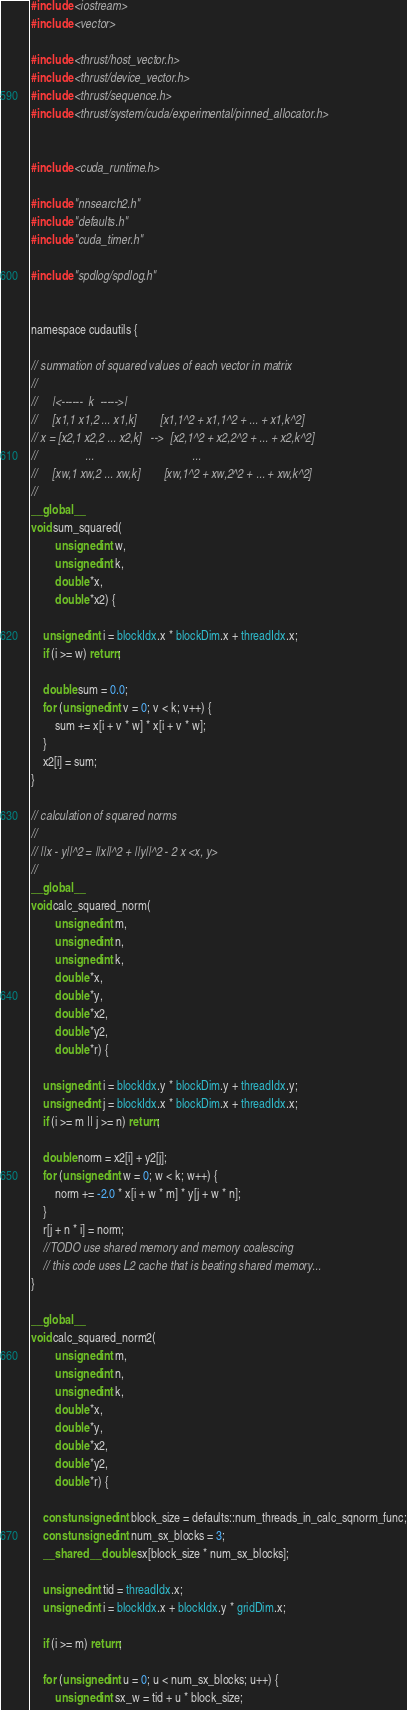Convert code to text. <code><loc_0><loc_0><loc_500><loc_500><_Cuda_>#include <iostream>
#include <vector>

#include <thrust/host_vector.h>
#include <thrust/device_vector.h>
#include <thrust/sequence.h>
#include <thrust/system/cuda/experimental/pinned_allocator.h>


#include <cuda_runtime.h>

#include "nnsearch2.h"
#include "defaults.h"
#include "cuda_timer.h"

#include "spdlog/spdlog.h"


namespace cudautils {

// summation of squared values of each vector in matrix
//
//     |<------  k  ----->|
//     [x1,1 x1,2 ... x1,k]        [x1,1^2 + x1,1^2 + ... + x1,k^2]
// x = [x2,1 x2,2 ... x2,k]   -->  [x2,1^2 + x2,2^2 + ... + x2,k^2]
//                ...                                 ...
//     [xw,1 xw,2 ... xw,k]        [xw,1^2 + xw,2^2 + ... + xw,k^2]
//
__global__
void sum_squared(
        unsigned int w,
        unsigned int k,
        double *x,
        double *x2) {

    unsigned int i = blockIdx.x * blockDim.x + threadIdx.x;
    if (i >= w) return;

    double sum = 0.0;
    for (unsigned int v = 0; v < k; v++) {
        sum += x[i + v * w] * x[i + v * w];
    }
    x2[i] = sum;
}

// calculation of squared norms
//
// ||x - y||^2 = ||x||^2 + ||y||^2 - 2 x <x, y>
//
__global__
void calc_squared_norm(
        unsigned int m,
        unsigned int n,
        unsigned int k,
        double *x,
        double *y,
        double *x2,
        double *y2,
        double *r) {

    unsigned int i = blockIdx.y * blockDim.y + threadIdx.y;
    unsigned int j = blockIdx.x * blockDim.x + threadIdx.x;
    if (i >= m || j >= n) return;

    double norm = x2[i] + y2[j];
    for (unsigned int w = 0; w < k; w++) {
        norm += -2.0 * x[i + w * m] * y[j + w * n];
    }
    r[j + n * i] = norm;
    //TODO use shared memory and memory coalescing
    // this code uses L2 cache that is beating shared memory...
}

__global__
void calc_squared_norm2(
        unsigned int m,
        unsigned int n,
        unsigned int k,
        double *x,
        double *y,
        double *x2,
        double *y2,
        double *r) {

    const unsigned int block_size = defaults::num_threads_in_calc_sqnorm_func;
    const unsigned int num_sx_blocks = 3;
    __shared__ double sx[block_size * num_sx_blocks];

    unsigned int tid = threadIdx.x;
    unsigned int i = blockIdx.x + blockIdx.y * gridDim.x;

    if (i >= m) return;

    for (unsigned int u = 0; u < num_sx_blocks; u++) {
        unsigned int sx_w = tid + u * block_size;</code> 